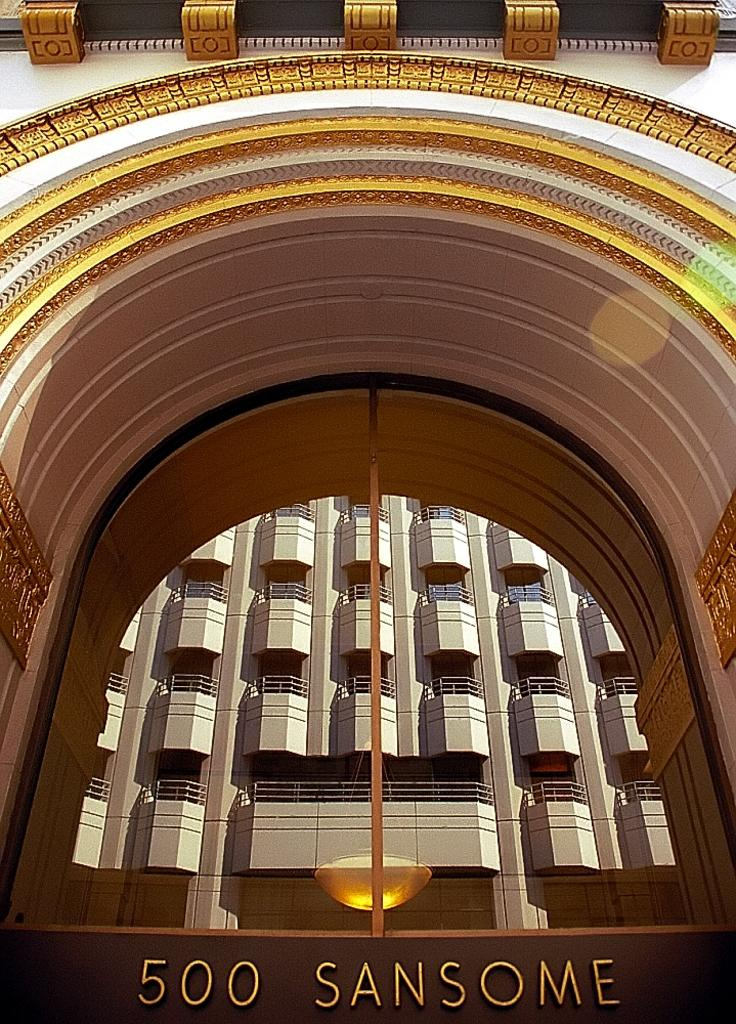What type of structure is visible in the image? There is a building in the image. What colors are used on the building? The building has cream, brown, and white colors. Is there any text or writing on the building? Yes, there is something written on the building. How many geese are standing on the scale in the image? There is no scale or geese present in the image. What type of afterthought is written on the building? There is no indication of an afterthought in the image, and the text on the building is not described as an afterthought. 